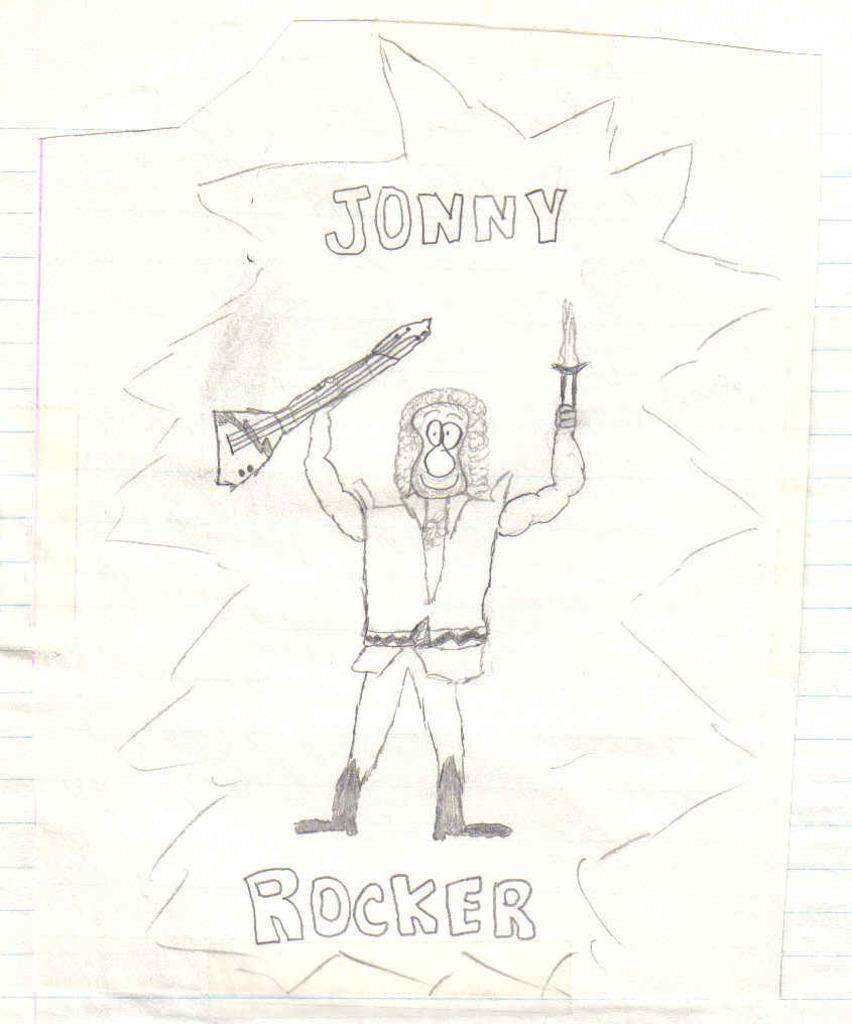What type of artwork is depicted in the image? The image is a sketch. What can be seen on top of the picture? There is text on top of the picture. What can be seen at the bottom of the picture? There is text at the bottom of the picture. Can you describe the person in the image? The person in the image is holding a guitar in one hand and an object in the other hand. What route does the person take to fold the judge in the image? There is no judge or folding action depicted in the image; it features a person holding a guitar and an object. 